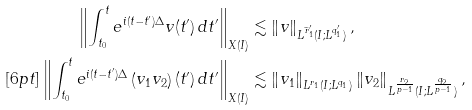<formula> <loc_0><loc_0><loc_500><loc_500>\left \| \int _ { t _ { 0 } } ^ { t } e ^ { i ( t - t ^ { \prime } ) \Delta } v ( t ^ { \prime } ) \, d t ^ { \prime } \right \| _ { X ( I ) } & \lesssim \left \| v \right \| _ { L ^ { \widetilde { r } _ { 1 } ^ { \prime } } ( I ; L ^ { q _ { 1 } ^ { \prime } } ) } , \\ [ 6 p t ] \left \| \int _ { t _ { 0 } } ^ { t } e ^ { i ( t - t ^ { \prime } ) \Delta } \left ( v _ { 1 } v _ { 2 } \right ) ( t ^ { \prime } ) \, d t ^ { \prime } \right \| _ { X ( I ) } & \lesssim \left \| v _ { 1 } \right \| _ { L ^ { r _ { 1 } } ( I ; L ^ { q _ { 1 } } ) } \left \| v _ { 2 } \right \| _ { L ^ { \frac { r _ { 2 } } { p - 1 } } ( I ; L ^ { \frac { q _ { 2 } } { p - 1 } } ) } ,</formula> 